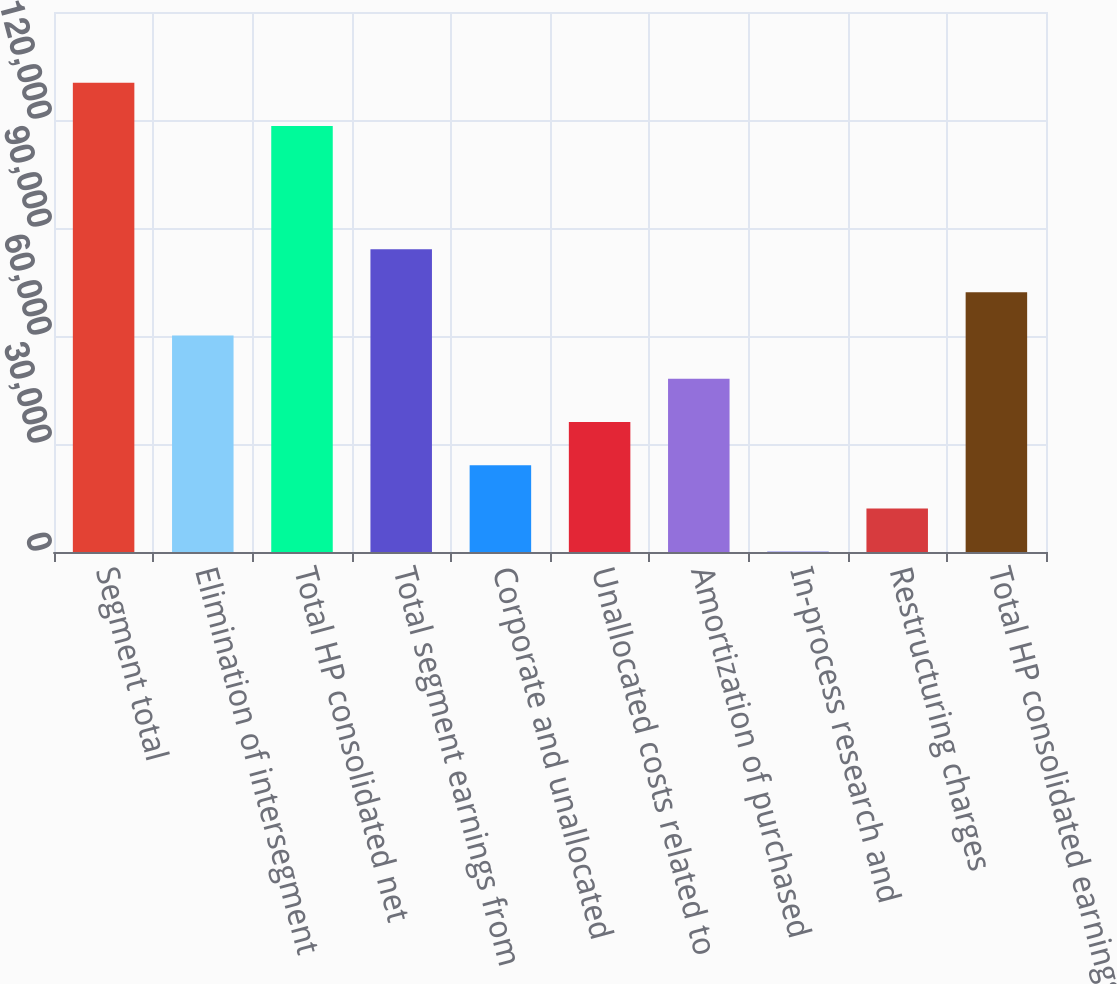Convert chart. <chart><loc_0><loc_0><loc_500><loc_500><bar_chart><fcel>Segment total<fcel>Elimination of intersegment<fcel>Total HP consolidated net<fcel>Total segment earnings from<fcel>Corporate and unallocated<fcel>Unallocated costs related to<fcel>Amortization of purchased<fcel>In-process research and<fcel>Restructuring charges<fcel>Total HP consolidated earnings<nl><fcel>130376<fcel>60107<fcel>118364<fcel>84131.8<fcel>24069.8<fcel>36082.2<fcel>48094.6<fcel>45<fcel>12057.4<fcel>72119.4<nl></chart> 